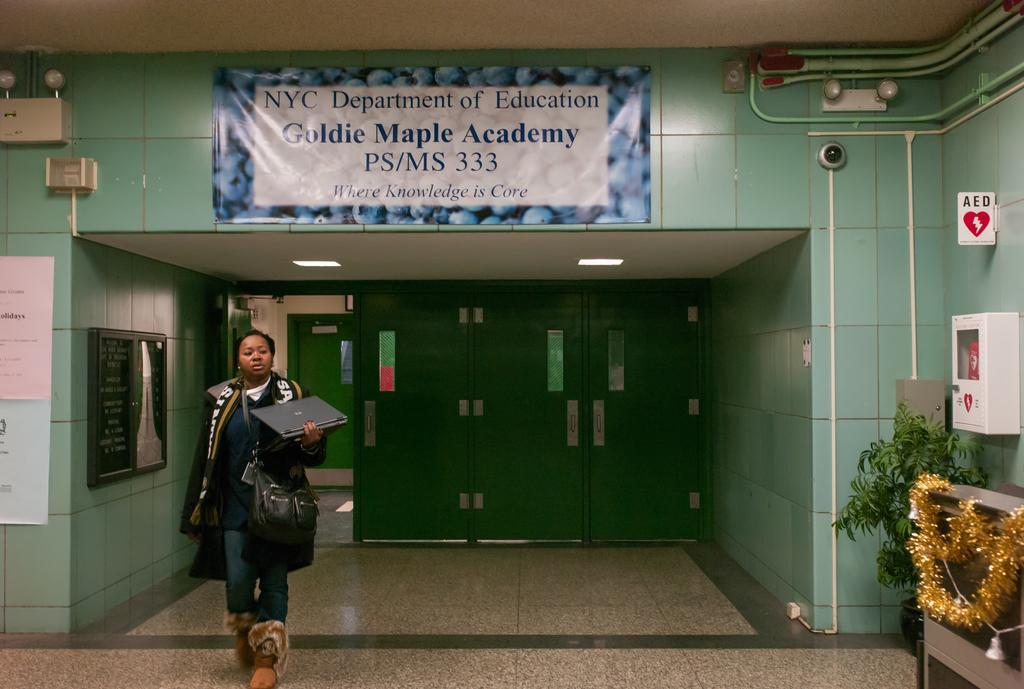Describe this image in one or two sentences. In this image I can see a woman is standing. I can see she is holding a laptop and she is carrying a bag. I can also see few boards, a plant, a golden colour thing, few pipes, few lights and on these boards I can see something is written. I can also see green colour doors in the background. 